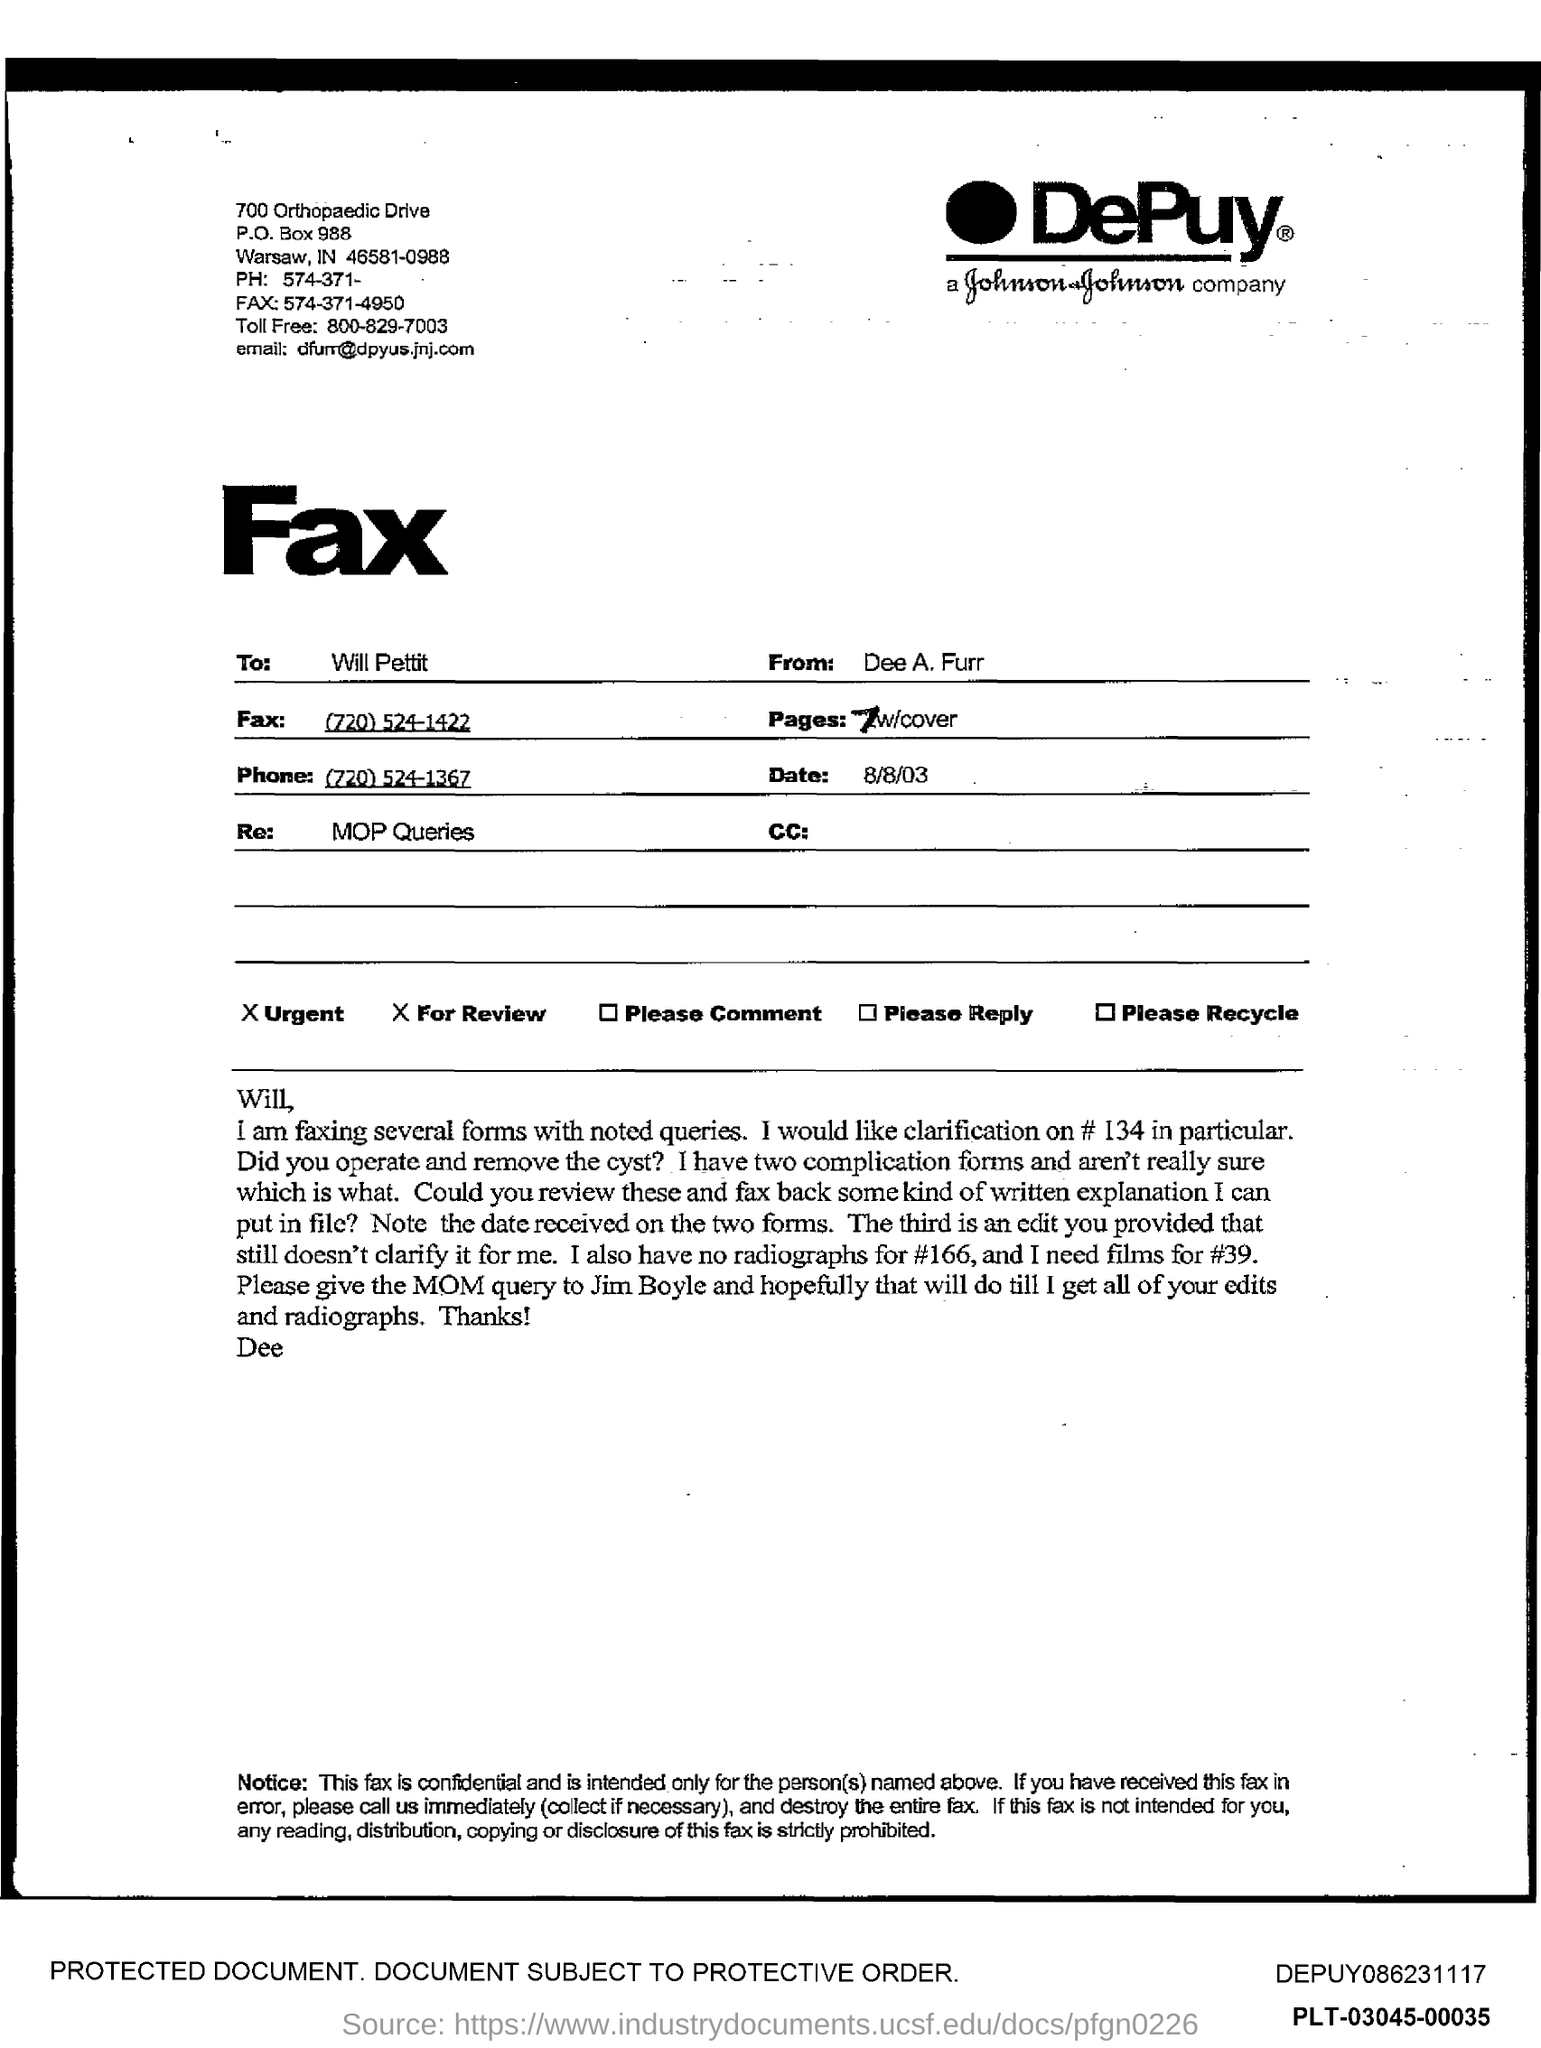Who is the fax addressed to, and what does it suggest about their role? The fax is addressed to 'Will Pettit,' suggesting that Will plays a role possibly in handling or overseeing medical operations or in the administrative processing of medical documents, given the context of needing clarification on medical procedures and patient cases. 